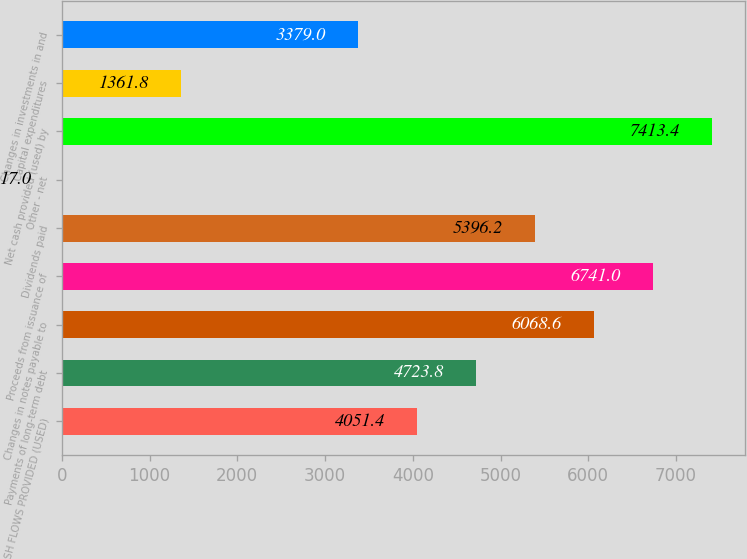Convert chart to OTSL. <chart><loc_0><loc_0><loc_500><loc_500><bar_chart><fcel>NET CASH FLOWS PROVIDED (USED)<fcel>Payments of long-term debt<fcel>Changes in notes payable to<fcel>Proceeds from issuance of<fcel>Dividends paid<fcel>Other - net<fcel>Net cash provided (used) by<fcel>Capital expenditures<fcel>Changes in investments in and<nl><fcel>4051.4<fcel>4723.8<fcel>6068.6<fcel>6741<fcel>5396.2<fcel>17<fcel>7413.4<fcel>1361.8<fcel>3379<nl></chart> 